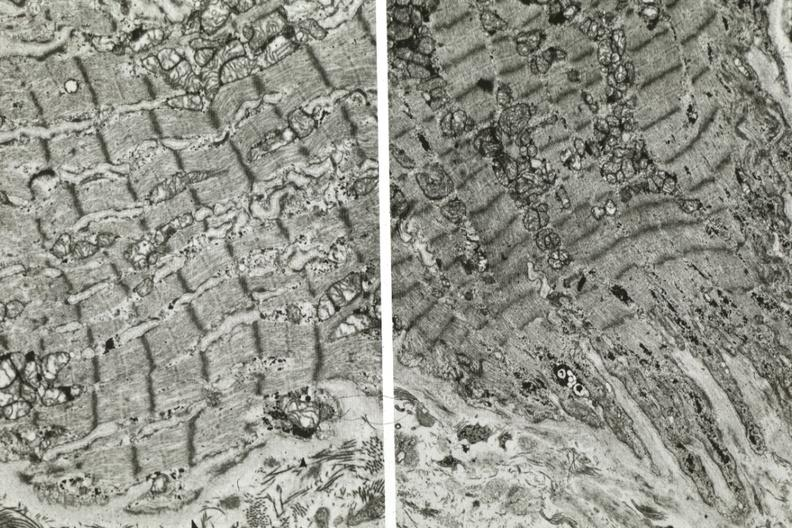what does not connect with another fiber other frame shows dilated sarcoplasmic reticulum?
Answer the question using a single word or phrase. Electron micrographs demonstrating 